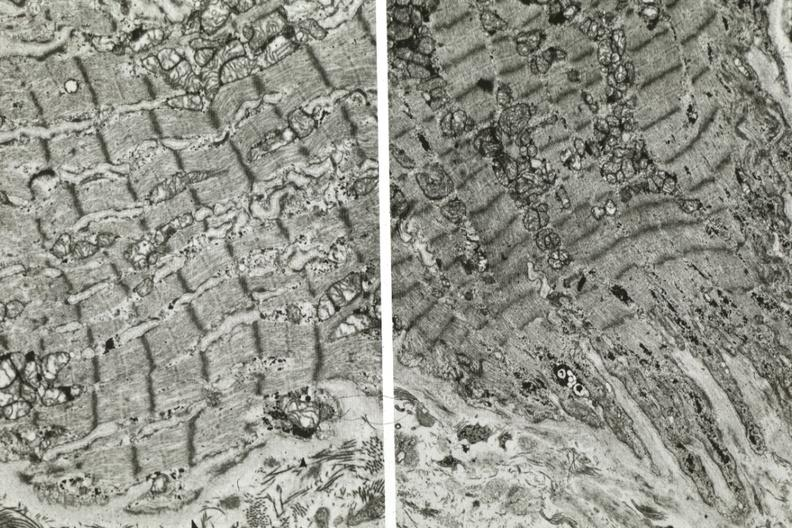what does not connect with another fiber other frame shows dilated sarcoplasmic reticulum?
Answer the question using a single word or phrase. Electron micrographs demonstrating 